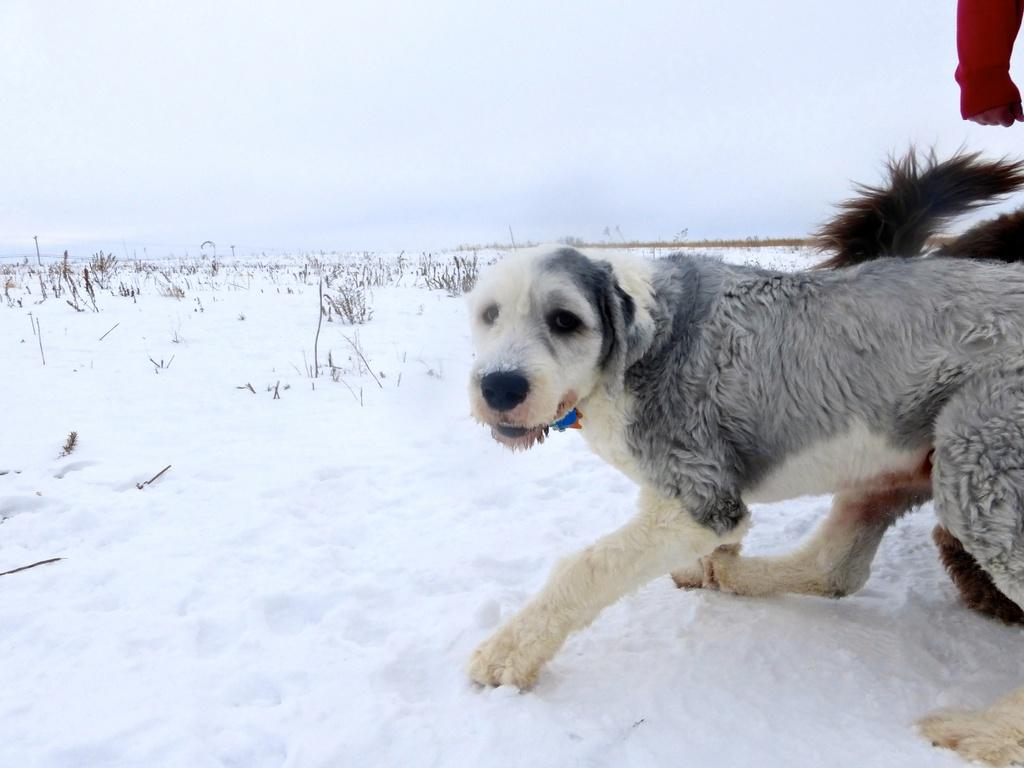What animals are present in the image? There are dogs in the image. What is the surface the dogs are standing on? The dogs are standing on the snow. What type of vegetation can be seen in the background of the image? There is grass visible in the background of the image. What else is visible in the background of the image? The sky is visible in the background of the image. What type of blade is being used by the dogs in the image? There is no blade present in the image; the dogs are simply standing on the snow. 